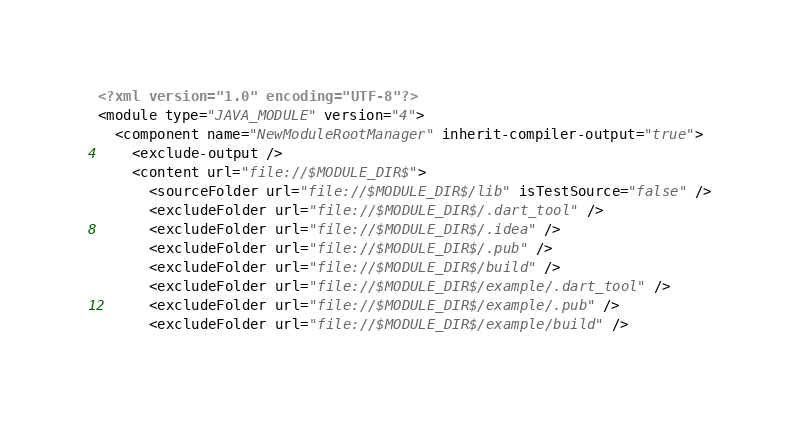Convert code to text. <code><loc_0><loc_0><loc_500><loc_500><_XML_><?xml version="1.0" encoding="UTF-8"?>
<module type="JAVA_MODULE" version="4">
  <component name="NewModuleRootManager" inherit-compiler-output="true">
    <exclude-output />
    <content url="file://$MODULE_DIR$">
      <sourceFolder url="file://$MODULE_DIR$/lib" isTestSource="false" />
      <excludeFolder url="file://$MODULE_DIR$/.dart_tool" />
      <excludeFolder url="file://$MODULE_DIR$/.idea" />
      <excludeFolder url="file://$MODULE_DIR$/.pub" />
      <excludeFolder url="file://$MODULE_DIR$/build" />
      <excludeFolder url="file://$MODULE_DIR$/example/.dart_tool" />
      <excludeFolder url="file://$MODULE_DIR$/example/.pub" />
      <excludeFolder url="file://$MODULE_DIR$/example/build" /></code> 